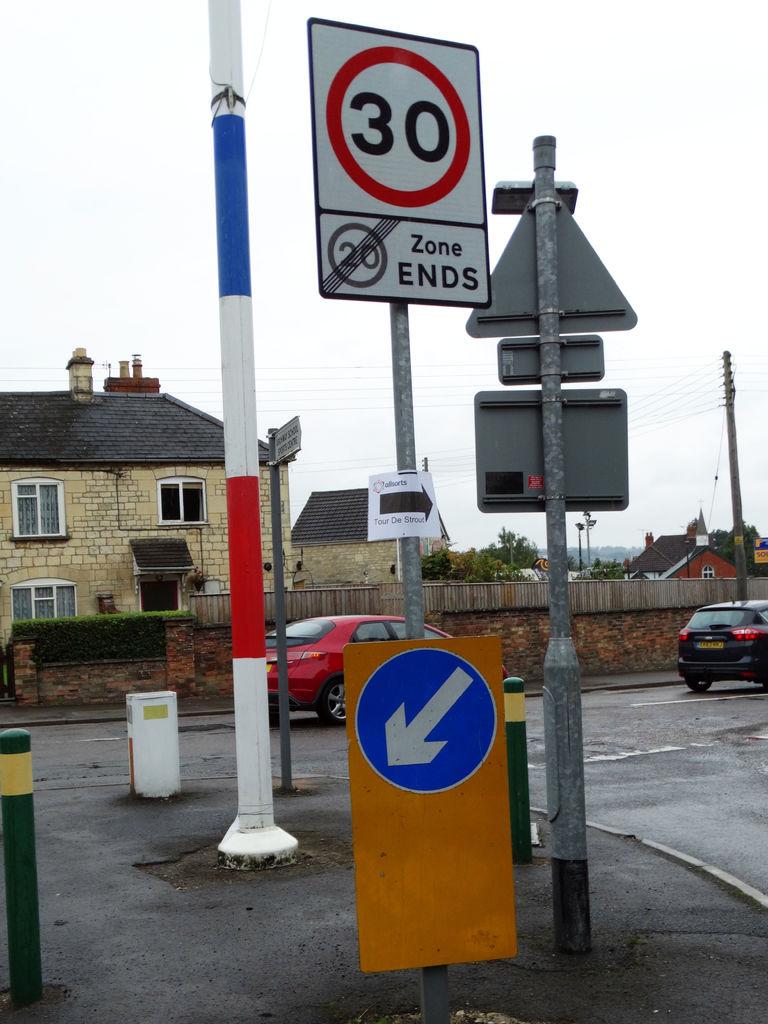What is the mph?
Offer a terse response. 30. What number is about the words zone ends?
Give a very brief answer. 20. 